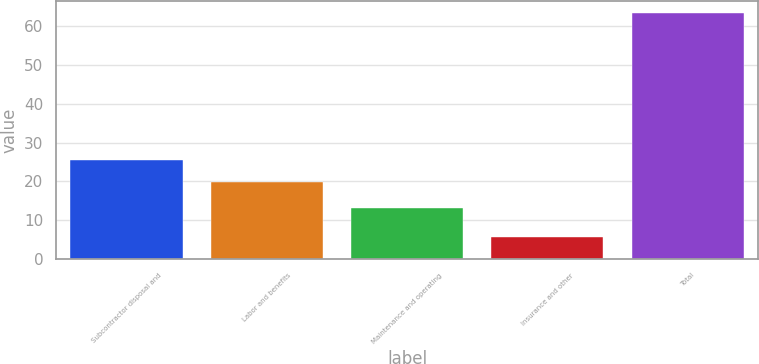<chart> <loc_0><loc_0><loc_500><loc_500><bar_chart><fcel>Subcontractor disposal and<fcel>Labor and benefits<fcel>Maintenance and operating<fcel>Insurance and other<fcel>Total<nl><fcel>25.56<fcel>19.8<fcel>13.1<fcel>5.7<fcel>63.3<nl></chart> 